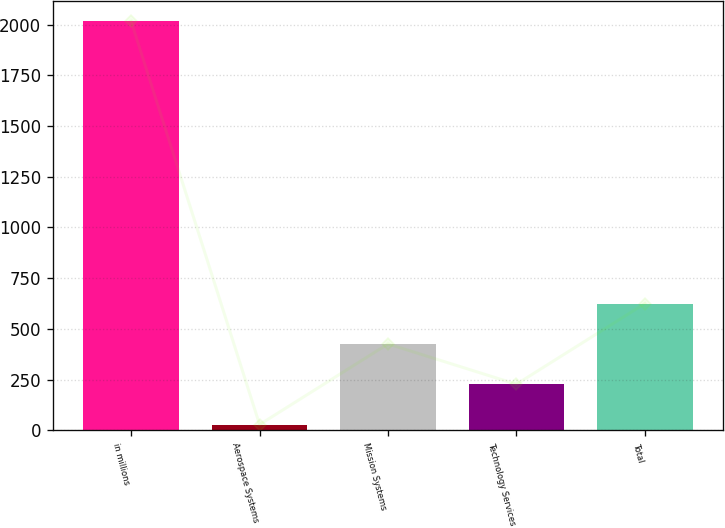Convert chart to OTSL. <chart><loc_0><loc_0><loc_500><loc_500><bar_chart><fcel>in millions<fcel>Aerospace Systems<fcel>Mission Systems<fcel>Technology Services<fcel>Total<nl><fcel>2016<fcel>28<fcel>425.6<fcel>226.8<fcel>624.4<nl></chart> 